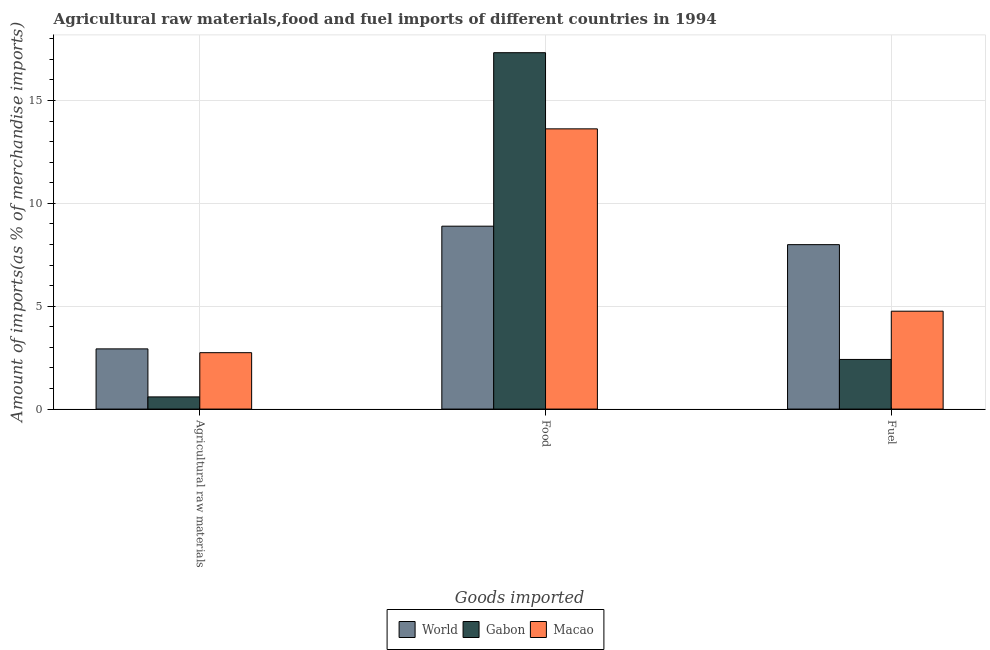How many different coloured bars are there?
Your answer should be compact. 3. How many groups of bars are there?
Keep it short and to the point. 3. Are the number of bars per tick equal to the number of legend labels?
Give a very brief answer. Yes. How many bars are there on the 1st tick from the left?
Offer a very short reply. 3. How many bars are there on the 2nd tick from the right?
Offer a very short reply. 3. What is the label of the 2nd group of bars from the left?
Provide a short and direct response. Food. What is the percentage of raw materials imports in Gabon?
Offer a terse response. 0.59. Across all countries, what is the maximum percentage of fuel imports?
Provide a short and direct response. 7.99. Across all countries, what is the minimum percentage of fuel imports?
Make the answer very short. 2.41. In which country was the percentage of fuel imports minimum?
Give a very brief answer. Gabon. What is the total percentage of food imports in the graph?
Provide a succinct answer. 39.84. What is the difference between the percentage of fuel imports in Macao and that in World?
Give a very brief answer. -3.24. What is the difference between the percentage of fuel imports in World and the percentage of food imports in Macao?
Give a very brief answer. -5.63. What is the average percentage of raw materials imports per country?
Offer a terse response. 2.09. What is the difference between the percentage of fuel imports and percentage of food imports in Gabon?
Make the answer very short. -14.91. What is the ratio of the percentage of food imports in World to that in Gabon?
Your answer should be compact. 0.51. Is the percentage of food imports in World less than that in Gabon?
Your answer should be compact. Yes. Is the difference between the percentage of raw materials imports in Gabon and World greater than the difference between the percentage of food imports in Gabon and World?
Your answer should be very brief. No. What is the difference between the highest and the second highest percentage of food imports?
Offer a very short reply. 3.7. What is the difference between the highest and the lowest percentage of fuel imports?
Your answer should be compact. 5.58. What does the 1st bar from the left in Fuel represents?
Your response must be concise. World. What does the 1st bar from the right in Fuel represents?
Provide a succinct answer. Macao. Is it the case that in every country, the sum of the percentage of raw materials imports and percentage of food imports is greater than the percentage of fuel imports?
Your answer should be very brief. Yes. Are all the bars in the graph horizontal?
Keep it short and to the point. No. How many countries are there in the graph?
Offer a terse response. 3. Does the graph contain any zero values?
Ensure brevity in your answer.  No. How many legend labels are there?
Your answer should be very brief. 3. What is the title of the graph?
Your answer should be very brief. Agricultural raw materials,food and fuel imports of different countries in 1994. What is the label or title of the X-axis?
Your answer should be very brief. Goods imported. What is the label or title of the Y-axis?
Your answer should be very brief. Amount of imports(as % of merchandise imports). What is the Amount of imports(as % of merchandise imports) in World in Agricultural raw materials?
Your response must be concise. 2.93. What is the Amount of imports(as % of merchandise imports) of Gabon in Agricultural raw materials?
Your answer should be compact. 0.59. What is the Amount of imports(as % of merchandise imports) of Macao in Agricultural raw materials?
Offer a very short reply. 2.74. What is the Amount of imports(as % of merchandise imports) in World in Food?
Provide a short and direct response. 8.89. What is the Amount of imports(as % of merchandise imports) of Gabon in Food?
Provide a succinct answer. 17.33. What is the Amount of imports(as % of merchandise imports) in Macao in Food?
Provide a succinct answer. 13.62. What is the Amount of imports(as % of merchandise imports) in World in Fuel?
Make the answer very short. 7.99. What is the Amount of imports(as % of merchandise imports) in Gabon in Fuel?
Ensure brevity in your answer.  2.41. What is the Amount of imports(as % of merchandise imports) in Macao in Fuel?
Ensure brevity in your answer.  4.76. Across all Goods imported, what is the maximum Amount of imports(as % of merchandise imports) of World?
Ensure brevity in your answer.  8.89. Across all Goods imported, what is the maximum Amount of imports(as % of merchandise imports) of Gabon?
Offer a very short reply. 17.33. Across all Goods imported, what is the maximum Amount of imports(as % of merchandise imports) in Macao?
Provide a succinct answer. 13.62. Across all Goods imported, what is the minimum Amount of imports(as % of merchandise imports) of World?
Give a very brief answer. 2.93. Across all Goods imported, what is the minimum Amount of imports(as % of merchandise imports) of Gabon?
Ensure brevity in your answer.  0.59. Across all Goods imported, what is the minimum Amount of imports(as % of merchandise imports) in Macao?
Offer a very short reply. 2.74. What is the total Amount of imports(as % of merchandise imports) of World in the graph?
Ensure brevity in your answer.  19.81. What is the total Amount of imports(as % of merchandise imports) in Gabon in the graph?
Ensure brevity in your answer.  20.33. What is the total Amount of imports(as % of merchandise imports) in Macao in the graph?
Offer a terse response. 21.12. What is the difference between the Amount of imports(as % of merchandise imports) of World in Agricultural raw materials and that in Food?
Provide a succinct answer. -5.97. What is the difference between the Amount of imports(as % of merchandise imports) in Gabon in Agricultural raw materials and that in Food?
Offer a terse response. -16.73. What is the difference between the Amount of imports(as % of merchandise imports) of Macao in Agricultural raw materials and that in Food?
Your answer should be compact. -10.88. What is the difference between the Amount of imports(as % of merchandise imports) of World in Agricultural raw materials and that in Fuel?
Provide a succinct answer. -5.07. What is the difference between the Amount of imports(as % of merchandise imports) in Gabon in Agricultural raw materials and that in Fuel?
Make the answer very short. -1.82. What is the difference between the Amount of imports(as % of merchandise imports) of Macao in Agricultural raw materials and that in Fuel?
Provide a short and direct response. -2.02. What is the difference between the Amount of imports(as % of merchandise imports) in World in Food and that in Fuel?
Your response must be concise. 0.9. What is the difference between the Amount of imports(as % of merchandise imports) of Gabon in Food and that in Fuel?
Offer a very short reply. 14.91. What is the difference between the Amount of imports(as % of merchandise imports) of Macao in Food and that in Fuel?
Provide a short and direct response. 8.86. What is the difference between the Amount of imports(as % of merchandise imports) in World in Agricultural raw materials and the Amount of imports(as % of merchandise imports) in Gabon in Food?
Ensure brevity in your answer.  -14.4. What is the difference between the Amount of imports(as % of merchandise imports) of World in Agricultural raw materials and the Amount of imports(as % of merchandise imports) of Macao in Food?
Make the answer very short. -10.7. What is the difference between the Amount of imports(as % of merchandise imports) in Gabon in Agricultural raw materials and the Amount of imports(as % of merchandise imports) in Macao in Food?
Provide a succinct answer. -13.03. What is the difference between the Amount of imports(as % of merchandise imports) of World in Agricultural raw materials and the Amount of imports(as % of merchandise imports) of Gabon in Fuel?
Offer a very short reply. 0.51. What is the difference between the Amount of imports(as % of merchandise imports) of World in Agricultural raw materials and the Amount of imports(as % of merchandise imports) of Macao in Fuel?
Provide a succinct answer. -1.83. What is the difference between the Amount of imports(as % of merchandise imports) in Gabon in Agricultural raw materials and the Amount of imports(as % of merchandise imports) in Macao in Fuel?
Your answer should be very brief. -4.17. What is the difference between the Amount of imports(as % of merchandise imports) of World in Food and the Amount of imports(as % of merchandise imports) of Gabon in Fuel?
Provide a short and direct response. 6.48. What is the difference between the Amount of imports(as % of merchandise imports) of World in Food and the Amount of imports(as % of merchandise imports) of Macao in Fuel?
Keep it short and to the point. 4.13. What is the difference between the Amount of imports(as % of merchandise imports) in Gabon in Food and the Amount of imports(as % of merchandise imports) in Macao in Fuel?
Your answer should be very brief. 12.57. What is the average Amount of imports(as % of merchandise imports) of World per Goods imported?
Offer a very short reply. 6.6. What is the average Amount of imports(as % of merchandise imports) of Gabon per Goods imported?
Provide a short and direct response. 6.78. What is the average Amount of imports(as % of merchandise imports) in Macao per Goods imported?
Make the answer very short. 7.04. What is the difference between the Amount of imports(as % of merchandise imports) of World and Amount of imports(as % of merchandise imports) of Gabon in Agricultural raw materials?
Make the answer very short. 2.33. What is the difference between the Amount of imports(as % of merchandise imports) of World and Amount of imports(as % of merchandise imports) of Macao in Agricultural raw materials?
Make the answer very short. 0.18. What is the difference between the Amount of imports(as % of merchandise imports) of Gabon and Amount of imports(as % of merchandise imports) of Macao in Agricultural raw materials?
Give a very brief answer. -2.15. What is the difference between the Amount of imports(as % of merchandise imports) in World and Amount of imports(as % of merchandise imports) in Gabon in Food?
Offer a very short reply. -8.43. What is the difference between the Amount of imports(as % of merchandise imports) of World and Amount of imports(as % of merchandise imports) of Macao in Food?
Your answer should be compact. -4.73. What is the difference between the Amount of imports(as % of merchandise imports) in Gabon and Amount of imports(as % of merchandise imports) in Macao in Food?
Give a very brief answer. 3.7. What is the difference between the Amount of imports(as % of merchandise imports) of World and Amount of imports(as % of merchandise imports) of Gabon in Fuel?
Your answer should be very brief. 5.58. What is the difference between the Amount of imports(as % of merchandise imports) in World and Amount of imports(as % of merchandise imports) in Macao in Fuel?
Provide a succinct answer. 3.24. What is the difference between the Amount of imports(as % of merchandise imports) of Gabon and Amount of imports(as % of merchandise imports) of Macao in Fuel?
Make the answer very short. -2.35. What is the ratio of the Amount of imports(as % of merchandise imports) of World in Agricultural raw materials to that in Food?
Make the answer very short. 0.33. What is the ratio of the Amount of imports(as % of merchandise imports) in Gabon in Agricultural raw materials to that in Food?
Make the answer very short. 0.03. What is the ratio of the Amount of imports(as % of merchandise imports) in Macao in Agricultural raw materials to that in Food?
Keep it short and to the point. 0.2. What is the ratio of the Amount of imports(as % of merchandise imports) in World in Agricultural raw materials to that in Fuel?
Provide a succinct answer. 0.37. What is the ratio of the Amount of imports(as % of merchandise imports) of Gabon in Agricultural raw materials to that in Fuel?
Provide a succinct answer. 0.25. What is the ratio of the Amount of imports(as % of merchandise imports) of Macao in Agricultural raw materials to that in Fuel?
Provide a succinct answer. 0.58. What is the ratio of the Amount of imports(as % of merchandise imports) in World in Food to that in Fuel?
Keep it short and to the point. 1.11. What is the ratio of the Amount of imports(as % of merchandise imports) of Gabon in Food to that in Fuel?
Keep it short and to the point. 7.18. What is the ratio of the Amount of imports(as % of merchandise imports) of Macao in Food to that in Fuel?
Your answer should be very brief. 2.86. What is the difference between the highest and the second highest Amount of imports(as % of merchandise imports) of World?
Offer a terse response. 0.9. What is the difference between the highest and the second highest Amount of imports(as % of merchandise imports) in Gabon?
Your answer should be compact. 14.91. What is the difference between the highest and the second highest Amount of imports(as % of merchandise imports) in Macao?
Your response must be concise. 8.86. What is the difference between the highest and the lowest Amount of imports(as % of merchandise imports) of World?
Offer a very short reply. 5.97. What is the difference between the highest and the lowest Amount of imports(as % of merchandise imports) of Gabon?
Your answer should be compact. 16.73. What is the difference between the highest and the lowest Amount of imports(as % of merchandise imports) in Macao?
Provide a short and direct response. 10.88. 